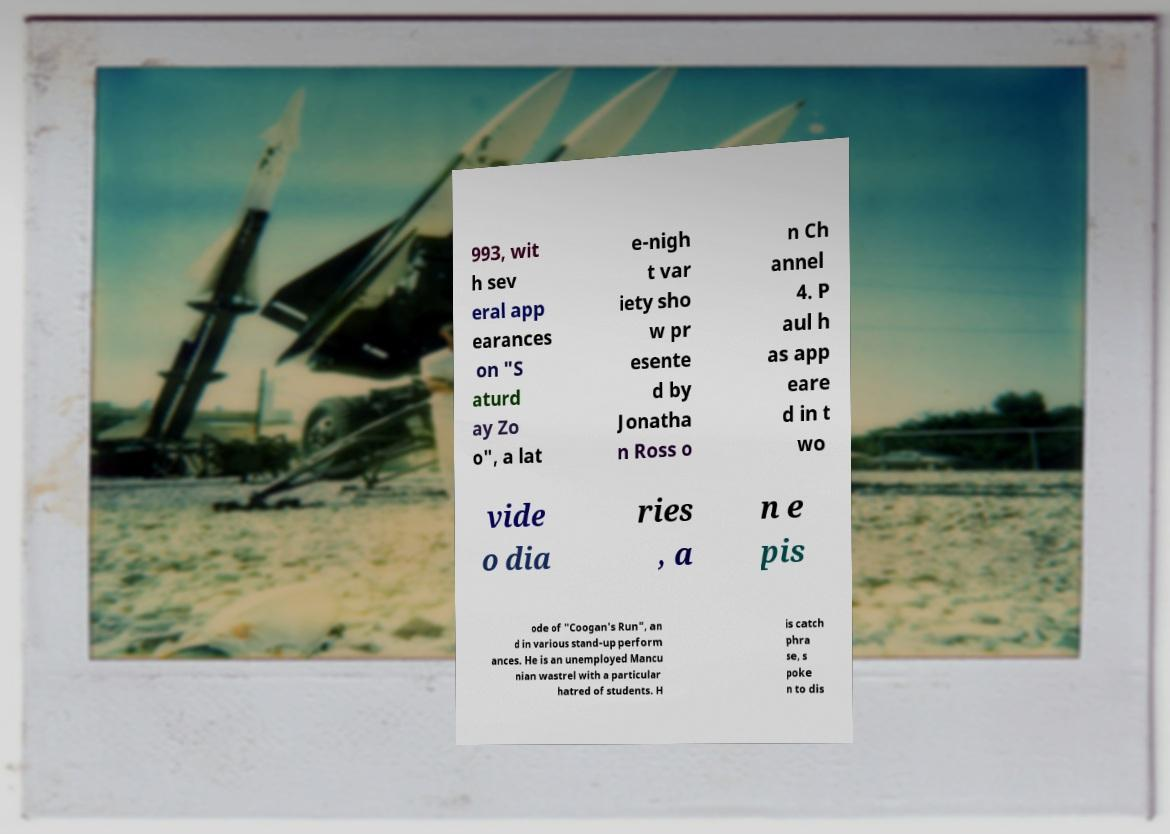What messages or text are displayed in this image? I need them in a readable, typed format. 993, wit h sev eral app earances on "S aturd ay Zo o", a lat e-nigh t var iety sho w pr esente d by Jonatha n Ross o n Ch annel 4. P aul h as app eare d in t wo vide o dia ries , a n e pis ode of "Coogan's Run", an d in various stand-up perform ances. He is an unemployed Mancu nian wastrel with a particular hatred of students. H is catch phra se, s poke n to dis 